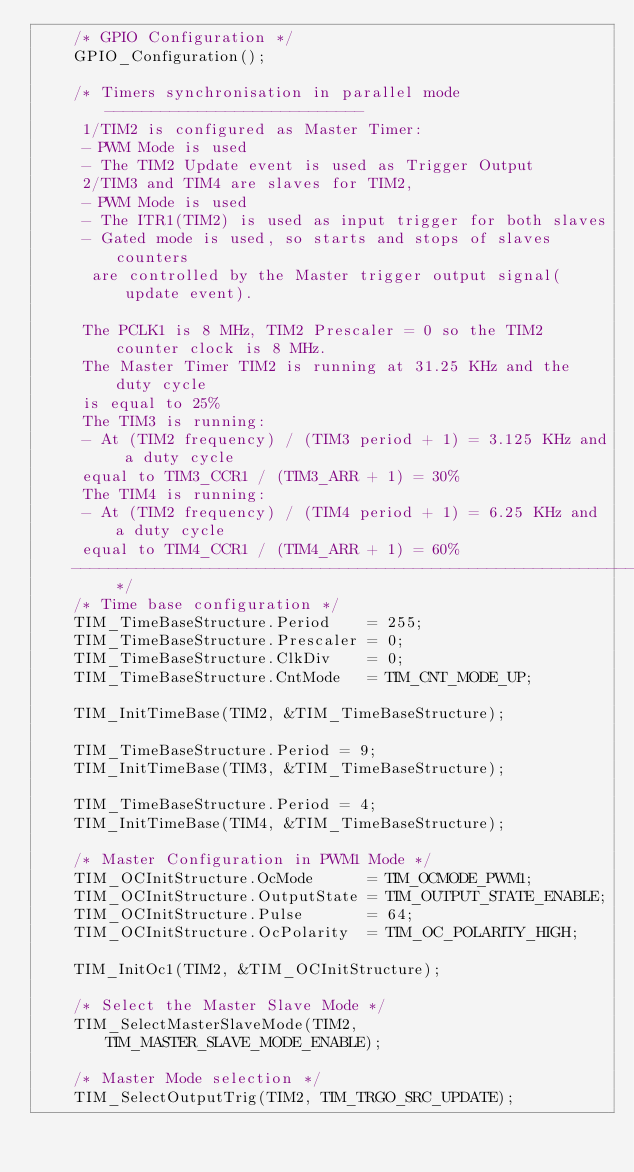<code> <loc_0><loc_0><loc_500><loc_500><_C_>    /* GPIO Configuration */
    GPIO_Configuration();

    /* Timers synchronisation in parallel mode ----------------------------
     1/TIM2 is configured as Master Timer:
     - PWM Mode is used
     - The TIM2 Update event is used as Trigger Output
     2/TIM3 and TIM4 are slaves for TIM2,
     - PWM Mode is used
     - The ITR1(TIM2) is used as input trigger for both slaves
     - Gated mode is used, so starts and stops of slaves counters
      are controlled by the Master trigger output signal(update event).

     The PCLK1 is 8 MHz, TIM2 Prescaler = 0 so the TIM2 counter clock is 8 MHz.
     The Master Timer TIM2 is running at 31.25 KHz and the duty cycle
     is equal to 25%
     The TIM3 is running:
     - At (TIM2 frequency) / (TIM3 period + 1) = 3.125 KHz and a duty cycle
     equal to TIM3_CCR1 / (TIM3_ARR + 1) = 30%
     The TIM4 is running:
     - At (TIM2 frequency) / (TIM4 period + 1) = 6.25 KHz and a duty cycle
     equal to TIM4_CCR1 / (TIM4_ARR + 1) = 60%
    -------------------------------------------------------------------- */
    /* Time base configuration */
    TIM_TimeBaseStructure.Period    = 255;
    TIM_TimeBaseStructure.Prescaler = 0;
    TIM_TimeBaseStructure.ClkDiv    = 0;
    TIM_TimeBaseStructure.CntMode   = TIM_CNT_MODE_UP;

    TIM_InitTimeBase(TIM2, &TIM_TimeBaseStructure);

    TIM_TimeBaseStructure.Period = 9;
    TIM_InitTimeBase(TIM3, &TIM_TimeBaseStructure);

    TIM_TimeBaseStructure.Period = 4;
    TIM_InitTimeBase(TIM4, &TIM_TimeBaseStructure);

    /* Master Configuration in PWM1 Mode */
    TIM_OCInitStructure.OcMode      = TIM_OCMODE_PWM1;
    TIM_OCInitStructure.OutputState = TIM_OUTPUT_STATE_ENABLE;
    TIM_OCInitStructure.Pulse       = 64;
    TIM_OCInitStructure.OcPolarity  = TIM_OC_POLARITY_HIGH;

    TIM_InitOc1(TIM2, &TIM_OCInitStructure);

    /* Select the Master Slave Mode */
    TIM_SelectMasterSlaveMode(TIM2, TIM_MASTER_SLAVE_MODE_ENABLE);

    /* Master Mode selection */
    TIM_SelectOutputTrig(TIM2, TIM_TRGO_SRC_UPDATE);
</code> 